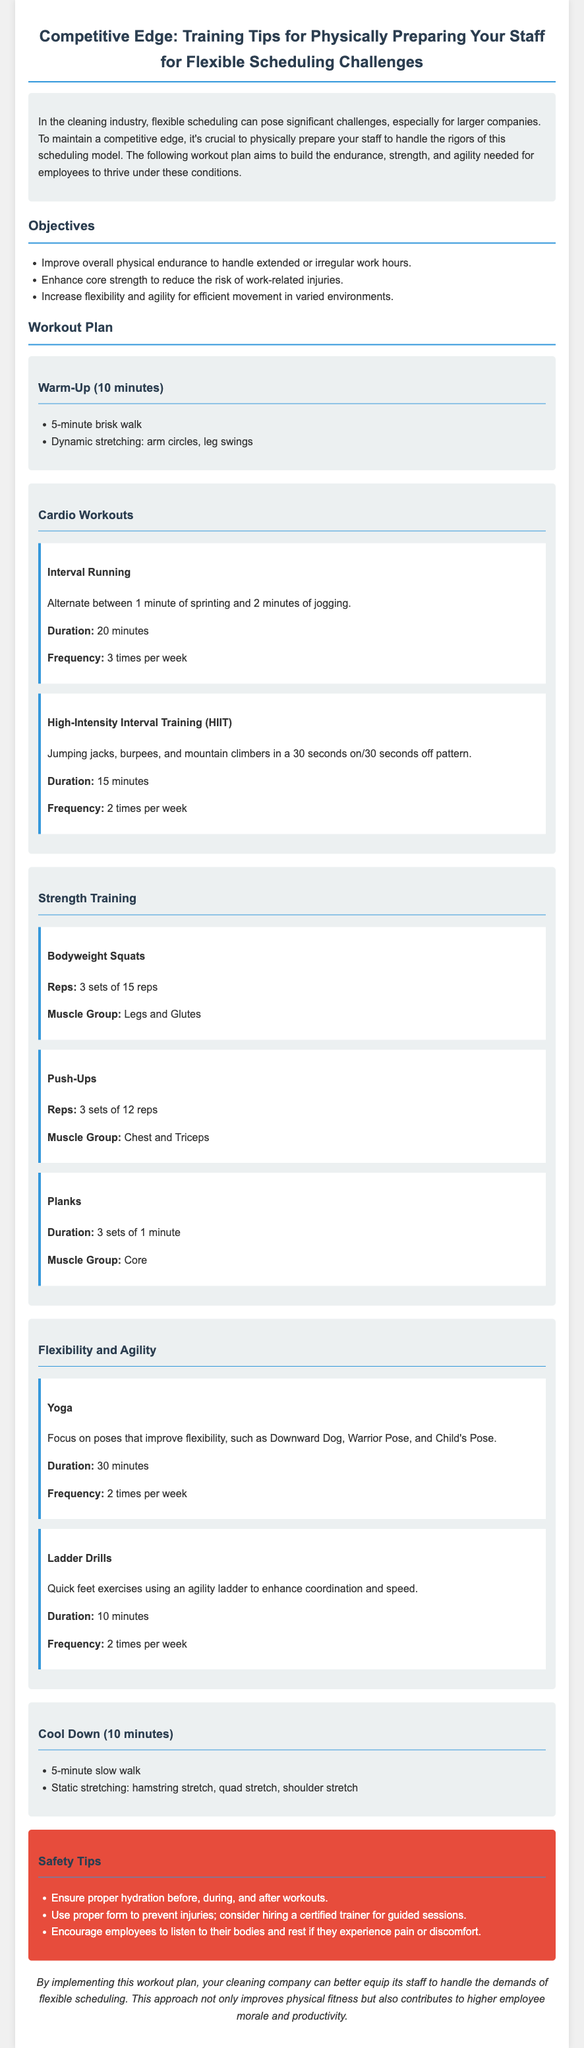What is the duration of the Interval Running workout? The duration of the Interval Running workout is specified in the workout plan section of the document.
Answer: 20 minutes How many times per week should HIIT be performed? The frequency of HIIT is outlined in the Cardio Workouts section.
Answer: 2 times per week What strength training exercise targets the chest and triceps? The workout plan lists push-ups as a strength training exercise for specific muscle groups.
Answer: Push-Ups What type of exercise is encouraged for improving flexibility? The document identifies yoga as an exercise aimed at enhancing flexibility among staff.
Answer: Yoga How long should the warm-up last? The warm-up duration is mentioned in the workout plan, indicating the time allocation for this segment.
Answer: 10 minutes What safety tip is provided regarding hydration? The safety tips highlight the importance of hydration in relation to workouts.
Answer: Ensure proper hydration How many sets of bodyweight squats are recommended? The workout structure specifies the sets for bodyweight squats under strength training.
Answer: 3 sets What is the purpose of the workout plan? The main goals of the workout plan are summarized in the introduction of the document.
Answer: To build endurance, strength, and agility What exercise is suggested to enhance coordination? The agility drills mentioned in the document are designed to improve coordination and speed.
Answer: Ladder Drills 